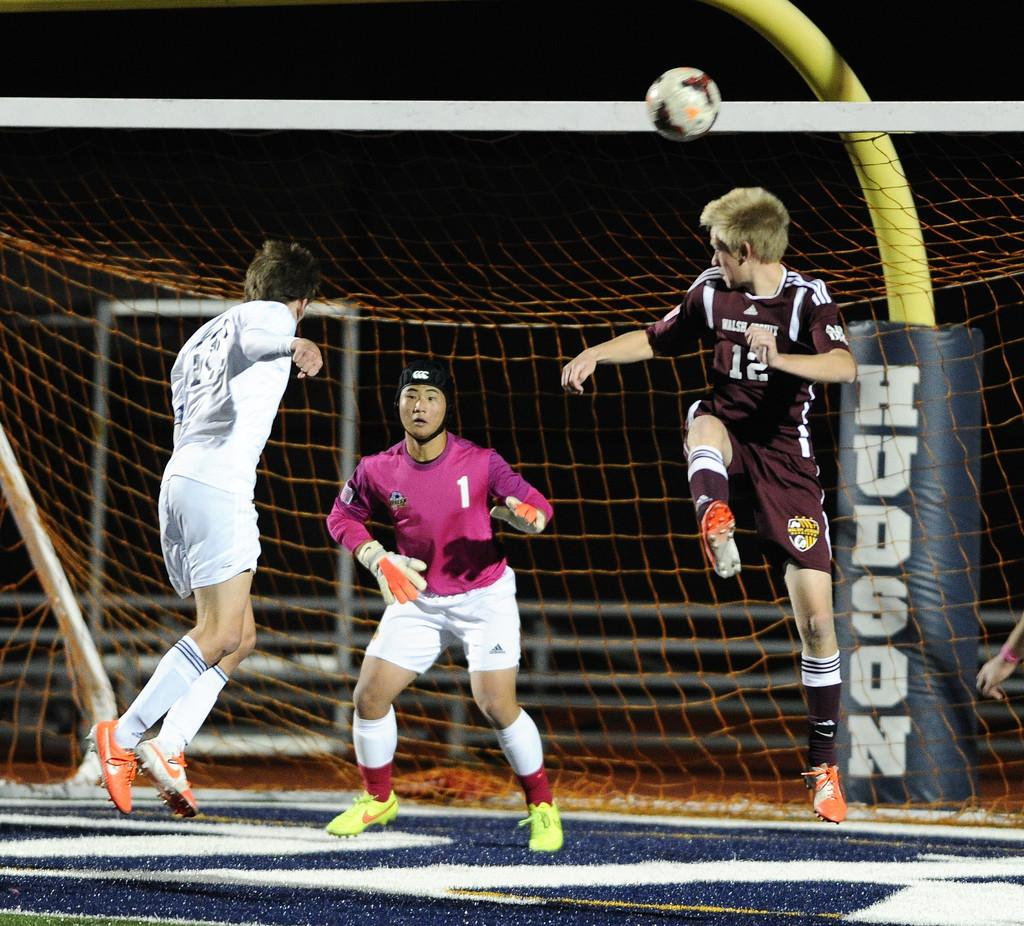Provide a one-sentence caption for the provided image. A soccer player with the number 12 on his jersey leaps into the air towards the goalie. 